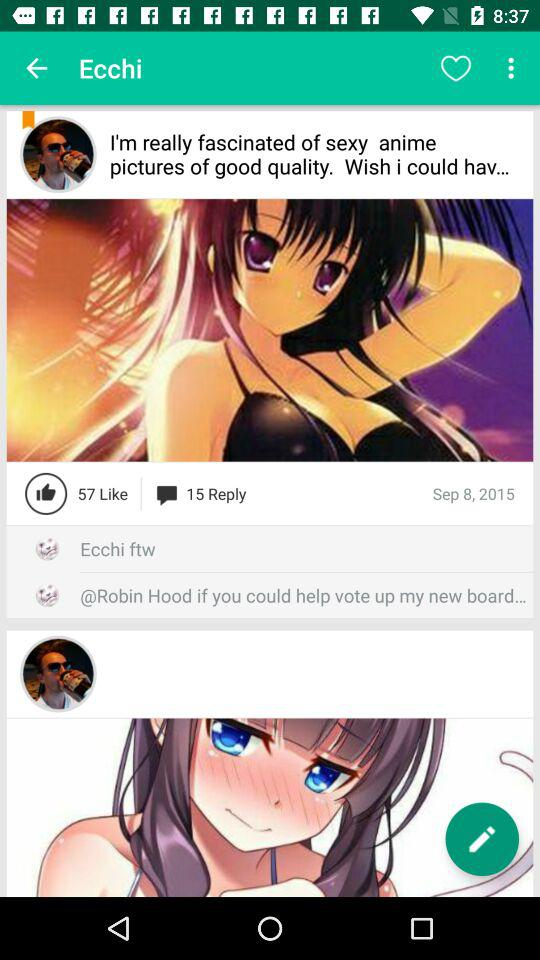How many replies are there to anime pictures posted? There are 57 likes. 